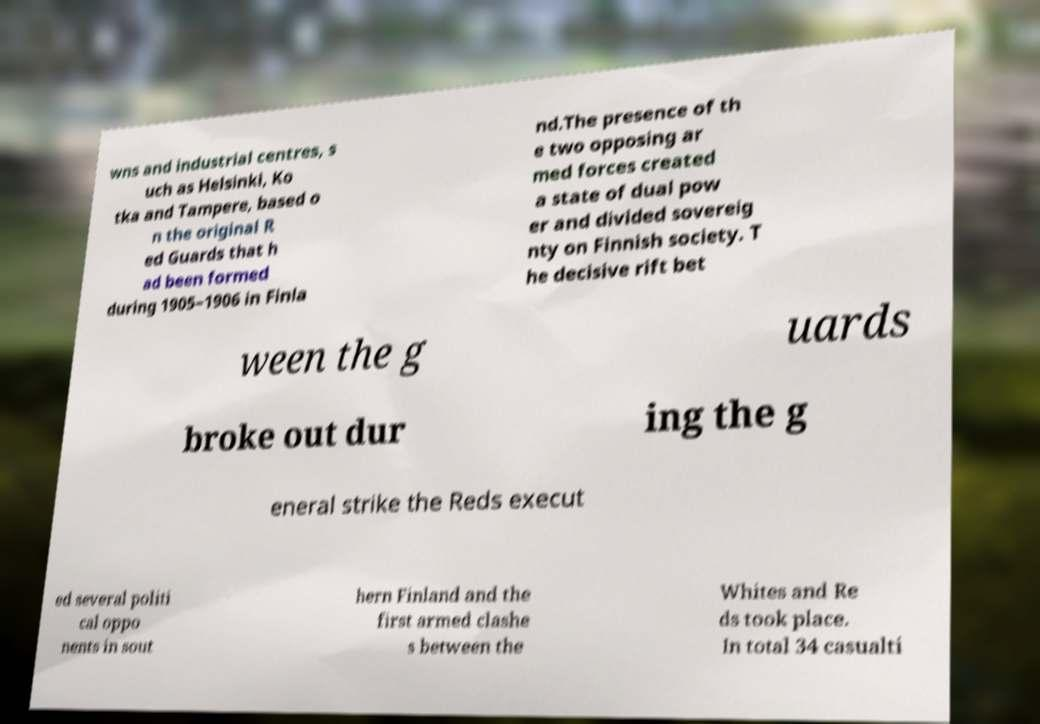Can you read and provide the text displayed in the image?This photo seems to have some interesting text. Can you extract and type it out for me? wns and industrial centres, s uch as Helsinki, Ko tka and Tampere, based o n the original R ed Guards that h ad been formed during 1905–1906 in Finla nd.The presence of th e two opposing ar med forces created a state of dual pow er and divided sovereig nty on Finnish society. T he decisive rift bet ween the g uards broke out dur ing the g eneral strike the Reds execut ed several politi cal oppo nents in sout hern Finland and the first armed clashe s between the Whites and Re ds took place. In total 34 casualti 